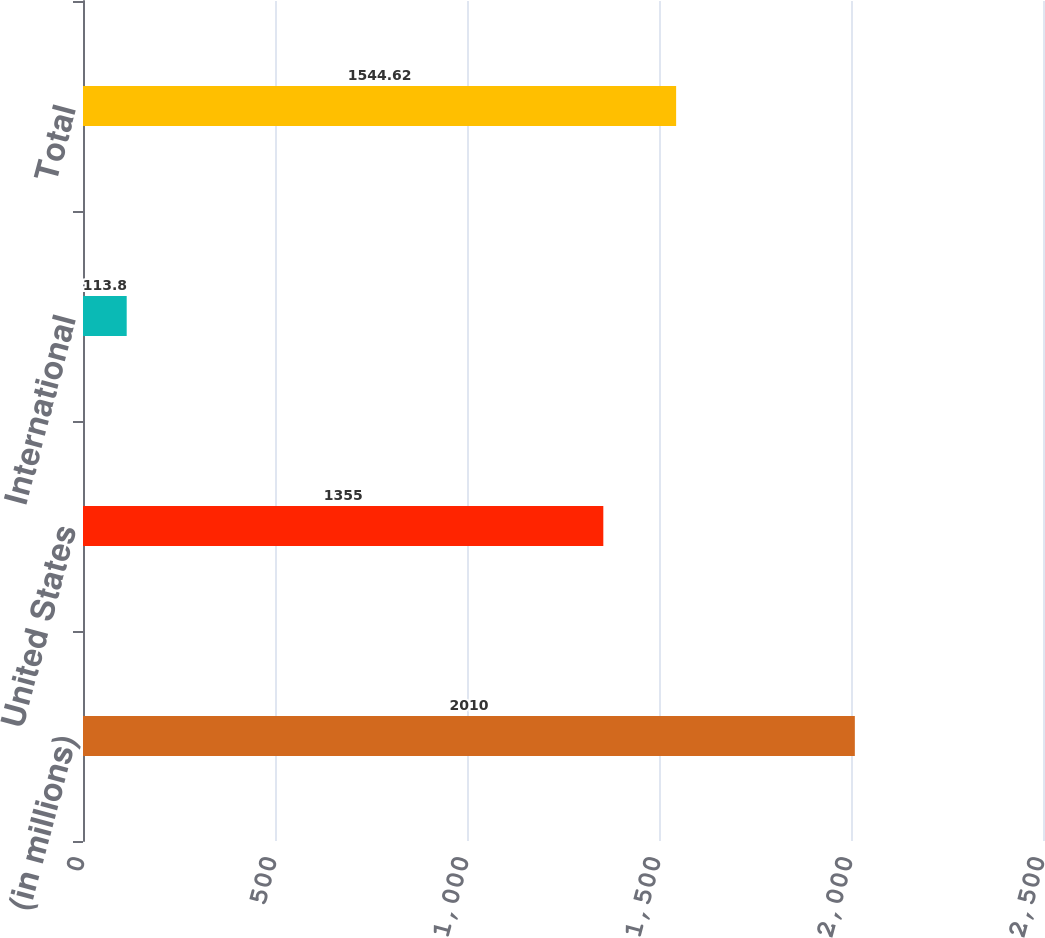<chart> <loc_0><loc_0><loc_500><loc_500><bar_chart><fcel>(in millions)<fcel>United States<fcel>International<fcel>Total<nl><fcel>2010<fcel>1355<fcel>113.8<fcel>1544.62<nl></chart> 